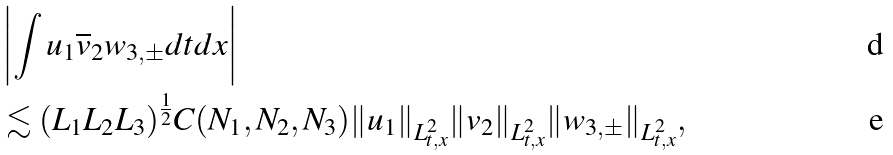Convert formula to latex. <formula><loc_0><loc_0><loc_500><loc_500>& \left | \int u _ { 1 } \overline { v } _ { 2 } w _ { 3 , \pm } d t d x \right | \\ & \lesssim ( L _ { 1 } L _ { 2 } L _ { 3 } ) ^ { \frac { 1 } { 2 } } C ( N _ { 1 } , N _ { 2 } , N _ { 3 } ) \| u _ { 1 } \| _ { L _ { t , x } ^ { 2 } } \| v _ { 2 } \| _ { L _ { t , x } ^ { 2 } } \| w _ { 3 , \pm } \| _ { L _ { t , x } ^ { 2 } } ,</formula> 